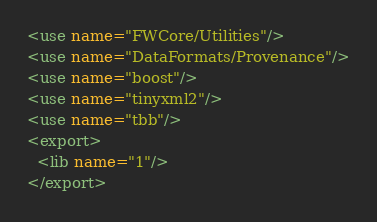<code> <loc_0><loc_0><loc_500><loc_500><_XML_><use name="FWCore/Utilities"/>
<use name="DataFormats/Provenance"/>
<use name="boost"/>
<use name="tinyxml2"/>
<use name="tbb"/>
<export>
  <lib name="1"/>
</export>
</code> 